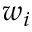Convert formula to latex. <formula><loc_0><loc_0><loc_500><loc_500>w _ { i }</formula> 